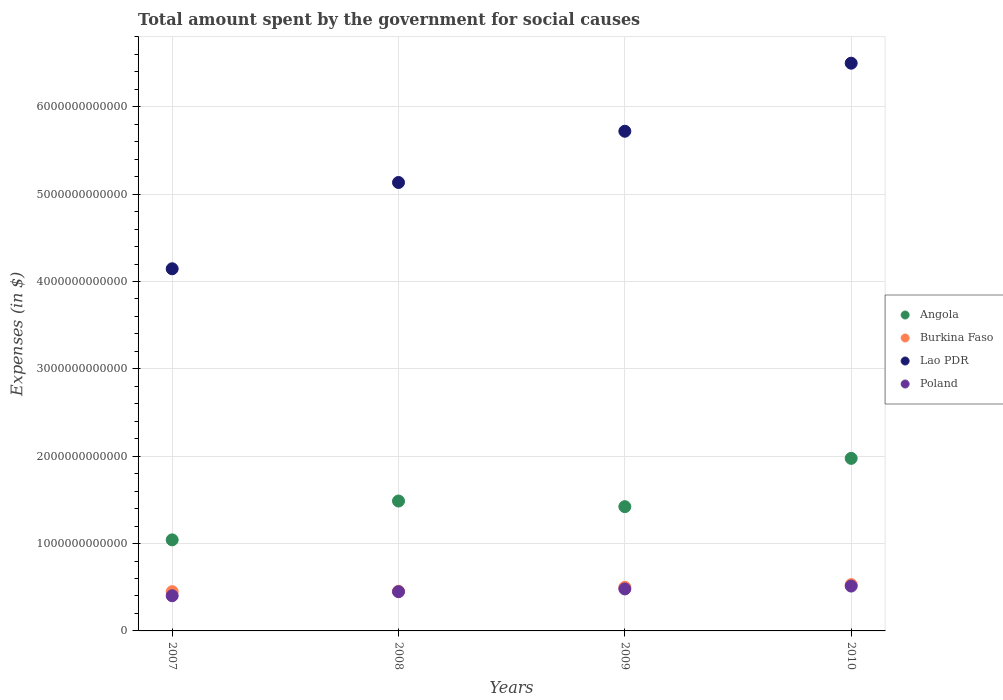How many different coloured dotlines are there?
Your response must be concise. 4. What is the amount spent for social causes by the government in Poland in 2009?
Offer a terse response. 4.81e+11. Across all years, what is the maximum amount spent for social causes by the government in Poland?
Make the answer very short. 5.13e+11. Across all years, what is the minimum amount spent for social causes by the government in Burkina Faso?
Make the answer very short. 4.49e+11. What is the total amount spent for social causes by the government in Poland in the graph?
Your answer should be very brief. 1.85e+12. What is the difference between the amount spent for social causes by the government in Lao PDR in 2009 and that in 2010?
Keep it short and to the point. -7.79e+11. What is the difference between the amount spent for social causes by the government in Poland in 2008 and the amount spent for social causes by the government in Angola in 2009?
Give a very brief answer. -9.73e+11. What is the average amount spent for social causes by the government in Lao PDR per year?
Your answer should be very brief. 5.37e+12. In the year 2009, what is the difference between the amount spent for social causes by the government in Angola and amount spent for social causes by the government in Lao PDR?
Provide a succinct answer. -4.30e+12. In how many years, is the amount spent for social causes by the government in Burkina Faso greater than 4000000000000 $?
Your response must be concise. 0. What is the ratio of the amount spent for social causes by the government in Angola in 2008 to that in 2009?
Give a very brief answer. 1.05. Is the amount spent for social causes by the government in Angola in 2009 less than that in 2010?
Make the answer very short. Yes. Is the difference between the amount spent for social causes by the government in Angola in 2007 and 2010 greater than the difference between the amount spent for social causes by the government in Lao PDR in 2007 and 2010?
Your response must be concise. Yes. What is the difference between the highest and the second highest amount spent for social causes by the government in Lao PDR?
Give a very brief answer. 7.79e+11. What is the difference between the highest and the lowest amount spent for social causes by the government in Angola?
Your answer should be compact. 9.33e+11. Is it the case that in every year, the sum of the amount spent for social causes by the government in Poland and amount spent for social causes by the government in Lao PDR  is greater than the sum of amount spent for social causes by the government in Angola and amount spent for social causes by the government in Burkina Faso?
Your response must be concise. No. Is it the case that in every year, the sum of the amount spent for social causes by the government in Poland and amount spent for social causes by the government in Burkina Faso  is greater than the amount spent for social causes by the government in Lao PDR?
Ensure brevity in your answer.  No. How many dotlines are there?
Offer a terse response. 4. What is the difference between two consecutive major ticks on the Y-axis?
Provide a short and direct response. 1.00e+12. Are the values on the major ticks of Y-axis written in scientific E-notation?
Your answer should be compact. No. Where does the legend appear in the graph?
Give a very brief answer. Center right. How many legend labels are there?
Make the answer very short. 4. What is the title of the graph?
Provide a succinct answer. Total amount spent by the government for social causes. What is the label or title of the X-axis?
Make the answer very short. Years. What is the label or title of the Y-axis?
Offer a very short reply. Expenses (in $). What is the Expenses (in $) in Angola in 2007?
Give a very brief answer. 1.04e+12. What is the Expenses (in $) of Burkina Faso in 2007?
Your response must be concise. 4.49e+11. What is the Expenses (in $) in Lao PDR in 2007?
Make the answer very short. 4.15e+12. What is the Expenses (in $) of Poland in 2007?
Offer a terse response. 4.03e+11. What is the Expenses (in $) in Angola in 2008?
Give a very brief answer. 1.49e+12. What is the Expenses (in $) of Burkina Faso in 2008?
Your response must be concise. 4.54e+11. What is the Expenses (in $) in Lao PDR in 2008?
Keep it short and to the point. 5.13e+12. What is the Expenses (in $) of Poland in 2008?
Offer a terse response. 4.49e+11. What is the Expenses (in $) in Angola in 2009?
Provide a succinct answer. 1.42e+12. What is the Expenses (in $) of Burkina Faso in 2009?
Keep it short and to the point. 4.99e+11. What is the Expenses (in $) of Lao PDR in 2009?
Keep it short and to the point. 5.72e+12. What is the Expenses (in $) in Poland in 2009?
Offer a terse response. 4.81e+11. What is the Expenses (in $) of Angola in 2010?
Ensure brevity in your answer.  1.98e+12. What is the Expenses (in $) of Burkina Faso in 2010?
Keep it short and to the point. 5.30e+11. What is the Expenses (in $) of Lao PDR in 2010?
Offer a terse response. 6.50e+12. What is the Expenses (in $) in Poland in 2010?
Offer a terse response. 5.13e+11. Across all years, what is the maximum Expenses (in $) in Angola?
Your answer should be very brief. 1.98e+12. Across all years, what is the maximum Expenses (in $) of Burkina Faso?
Your response must be concise. 5.30e+11. Across all years, what is the maximum Expenses (in $) of Lao PDR?
Ensure brevity in your answer.  6.50e+12. Across all years, what is the maximum Expenses (in $) in Poland?
Keep it short and to the point. 5.13e+11. Across all years, what is the minimum Expenses (in $) of Angola?
Ensure brevity in your answer.  1.04e+12. Across all years, what is the minimum Expenses (in $) in Burkina Faso?
Offer a very short reply. 4.49e+11. Across all years, what is the minimum Expenses (in $) of Lao PDR?
Your response must be concise. 4.15e+12. Across all years, what is the minimum Expenses (in $) in Poland?
Make the answer very short. 4.03e+11. What is the total Expenses (in $) of Angola in the graph?
Give a very brief answer. 5.93e+12. What is the total Expenses (in $) in Burkina Faso in the graph?
Give a very brief answer. 1.93e+12. What is the total Expenses (in $) of Lao PDR in the graph?
Offer a terse response. 2.15e+13. What is the total Expenses (in $) of Poland in the graph?
Your response must be concise. 1.85e+12. What is the difference between the Expenses (in $) in Angola in 2007 and that in 2008?
Offer a very short reply. -4.45e+11. What is the difference between the Expenses (in $) in Burkina Faso in 2007 and that in 2008?
Provide a short and direct response. -4.22e+09. What is the difference between the Expenses (in $) in Lao PDR in 2007 and that in 2008?
Give a very brief answer. -9.88e+11. What is the difference between the Expenses (in $) of Poland in 2007 and that in 2008?
Your answer should be compact. -4.65e+1. What is the difference between the Expenses (in $) in Angola in 2007 and that in 2009?
Offer a terse response. -3.80e+11. What is the difference between the Expenses (in $) in Burkina Faso in 2007 and that in 2009?
Offer a very short reply. -4.97e+1. What is the difference between the Expenses (in $) in Lao PDR in 2007 and that in 2009?
Your answer should be very brief. -1.57e+12. What is the difference between the Expenses (in $) of Poland in 2007 and that in 2009?
Keep it short and to the point. -7.78e+1. What is the difference between the Expenses (in $) of Angola in 2007 and that in 2010?
Give a very brief answer. -9.33e+11. What is the difference between the Expenses (in $) in Burkina Faso in 2007 and that in 2010?
Make the answer very short. -8.05e+1. What is the difference between the Expenses (in $) in Lao PDR in 2007 and that in 2010?
Your answer should be compact. -2.35e+12. What is the difference between the Expenses (in $) in Poland in 2007 and that in 2010?
Ensure brevity in your answer.  -1.11e+11. What is the difference between the Expenses (in $) of Angola in 2008 and that in 2009?
Give a very brief answer. 6.45e+1. What is the difference between the Expenses (in $) of Burkina Faso in 2008 and that in 2009?
Ensure brevity in your answer.  -4.54e+1. What is the difference between the Expenses (in $) of Lao PDR in 2008 and that in 2009?
Provide a short and direct response. -5.87e+11. What is the difference between the Expenses (in $) in Poland in 2008 and that in 2009?
Keep it short and to the point. -3.14e+1. What is the difference between the Expenses (in $) in Angola in 2008 and that in 2010?
Keep it short and to the point. -4.88e+11. What is the difference between the Expenses (in $) of Burkina Faso in 2008 and that in 2010?
Make the answer very short. -7.63e+1. What is the difference between the Expenses (in $) of Lao PDR in 2008 and that in 2010?
Provide a short and direct response. -1.37e+12. What is the difference between the Expenses (in $) of Poland in 2008 and that in 2010?
Give a very brief answer. -6.41e+1. What is the difference between the Expenses (in $) of Angola in 2009 and that in 2010?
Provide a succinct answer. -5.53e+11. What is the difference between the Expenses (in $) of Burkina Faso in 2009 and that in 2010?
Provide a succinct answer. -3.09e+1. What is the difference between the Expenses (in $) of Lao PDR in 2009 and that in 2010?
Give a very brief answer. -7.79e+11. What is the difference between the Expenses (in $) in Poland in 2009 and that in 2010?
Your answer should be compact. -3.28e+1. What is the difference between the Expenses (in $) in Angola in 2007 and the Expenses (in $) in Burkina Faso in 2008?
Give a very brief answer. 5.89e+11. What is the difference between the Expenses (in $) of Angola in 2007 and the Expenses (in $) of Lao PDR in 2008?
Your answer should be compact. -4.09e+12. What is the difference between the Expenses (in $) of Angola in 2007 and the Expenses (in $) of Poland in 2008?
Offer a very short reply. 5.93e+11. What is the difference between the Expenses (in $) of Burkina Faso in 2007 and the Expenses (in $) of Lao PDR in 2008?
Your answer should be compact. -4.68e+12. What is the difference between the Expenses (in $) of Burkina Faso in 2007 and the Expenses (in $) of Poland in 2008?
Provide a short and direct response. 1.53e+08. What is the difference between the Expenses (in $) in Lao PDR in 2007 and the Expenses (in $) in Poland in 2008?
Give a very brief answer. 3.70e+12. What is the difference between the Expenses (in $) of Angola in 2007 and the Expenses (in $) of Burkina Faso in 2009?
Provide a succinct answer. 5.43e+11. What is the difference between the Expenses (in $) in Angola in 2007 and the Expenses (in $) in Lao PDR in 2009?
Ensure brevity in your answer.  -4.68e+12. What is the difference between the Expenses (in $) of Angola in 2007 and the Expenses (in $) of Poland in 2009?
Offer a terse response. 5.62e+11. What is the difference between the Expenses (in $) of Burkina Faso in 2007 and the Expenses (in $) of Lao PDR in 2009?
Your answer should be very brief. -5.27e+12. What is the difference between the Expenses (in $) in Burkina Faso in 2007 and the Expenses (in $) in Poland in 2009?
Your answer should be very brief. -3.12e+1. What is the difference between the Expenses (in $) of Lao PDR in 2007 and the Expenses (in $) of Poland in 2009?
Make the answer very short. 3.67e+12. What is the difference between the Expenses (in $) of Angola in 2007 and the Expenses (in $) of Burkina Faso in 2010?
Offer a terse response. 5.13e+11. What is the difference between the Expenses (in $) of Angola in 2007 and the Expenses (in $) of Lao PDR in 2010?
Offer a terse response. -5.46e+12. What is the difference between the Expenses (in $) in Angola in 2007 and the Expenses (in $) in Poland in 2010?
Your answer should be compact. 5.29e+11. What is the difference between the Expenses (in $) of Burkina Faso in 2007 and the Expenses (in $) of Lao PDR in 2010?
Keep it short and to the point. -6.05e+12. What is the difference between the Expenses (in $) in Burkina Faso in 2007 and the Expenses (in $) in Poland in 2010?
Your answer should be very brief. -6.40e+1. What is the difference between the Expenses (in $) of Lao PDR in 2007 and the Expenses (in $) of Poland in 2010?
Offer a terse response. 3.63e+12. What is the difference between the Expenses (in $) in Angola in 2008 and the Expenses (in $) in Burkina Faso in 2009?
Offer a terse response. 9.88e+11. What is the difference between the Expenses (in $) in Angola in 2008 and the Expenses (in $) in Lao PDR in 2009?
Offer a terse response. -4.23e+12. What is the difference between the Expenses (in $) of Angola in 2008 and the Expenses (in $) of Poland in 2009?
Your response must be concise. 1.01e+12. What is the difference between the Expenses (in $) of Burkina Faso in 2008 and the Expenses (in $) of Lao PDR in 2009?
Your response must be concise. -5.27e+12. What is the difference between the Expenses (in $) in Burkina Faso in 2008 and the Expenses (in $) in Poland in 2009?
Offer a terse response. -2.70e+1. What is the difference between the Expenses (in $) of Lao PDR in 2008 and the Expenses (in $) of Poland in 2009?
Provide a short and direct response. 4.65e+12. What is the difference between the Expenses (in $) of Angola in 2008 and the Expenses (in $) of Burkina Faso in 2010?
Ensure brevity in your answer.  9.57e+11. What is the difference between the Expenses (in $) of Angola in 2008 and the Expenses (in $) of Lao PDR in 2010?
Give a very brief answer. -5.01e+12. What is the difference between the Expenses (in $) in Angola in 2008 and the Expenses (in $) in Poland in 2010?
Your response must be concise. 9.74e+11. What is the difference between the Expenses (in $) of Burkina Faso in 2008 and the Expenses (in $) of Lao PDR in 2010?
Ensure brevity in your answer.  -6.05e+12. What is the difference between the Expenses (in $) of Burkina Faso in 2008 and the Expenses (in $) of Poland in 2010?
Give a very brief answer. -5.98e+1. What is the difference between the Expenses (in $) of Lao PDR in 2008 and the Expenses (in $) of Poland in 2010?
Provide a short and direct response. 4.62e+12. What is the difference between the Expenses (in $) of Angola in 2009 and the Expenses (in $) of Burkina Faso in 2010?
Your answer should be very brief. 8.93e+11. What is the difference between the Expenses (in $) in Angola in 2009 and the Expenses (in $) in Lao PDR in 2010?
Ensure brevity in your answer.  -5.08e+12. What is the difference between the Expenses (in $) of Angola in 2009 and the Expenses (in $) of Poland in 2010?
Your response must be concise. 9.09e+11. What is the difference between the Expenses (in $) of Burkina Faso in 2009 and the Expenses (in $) of Lao PDR in 2010?
Provide a short and direct response. -6.00e+12. What is the difference between the Expenses (in $) of Burkina Faso in 2009 and the Expenses (in $) of Poland in 2010?
Your answer should be very brief. -1.43e+1. What is the difference between the Expenses (in $) in Lao PDR in 2009 and the Expenses (in $) in Poland in 2010?
Provide a short and direct response. 5.21e+12. What is the average Expenses (in $) of Angola per year?
Make the answer very short. 1.48e+12. What is the average Expenses (in $) in Burkina Faso per year?
Provide a succinct answer. 4.83e+11. What is the average Expenses (in $) of Lao PDR per year?
Offer a very short reply. 5.37e+12. What is the average Expenses (in $) in Poland per year?
Give a very brief answer. 4.62e+11. In the year 2007, what is the difference between the Expenses (in $) of Angola and Expenses (in $) of Burkina Faso?
Provide a succinct answer. 5.93e+11. In the year 2007, what is the difference between the Expenses (in $) in Angola and Expenses (in $) in Lao PDR?
Keep it short and to the point. -3.10e+12. In the year 2007, what is the difference between the Expenses (in $) of Angola and Expenses (in $) of Poland?
Offer a terse response. 6.40e+11. In the year 2007, what is the difference between the Expenses (in $) in Burkina Faso and Expenses (in $) in Lao PDR?
Give a very brief answer. -3.70e+12. In the year 2007, what is the difference between the Expenses (in $) of Burkina Faso and Expenses (in $) of Poland?
Ensure brevity in your answer.  4.66e+1. In the year 2007, what is the difference between the Expenses (in $) in Lao PDR and Expenses (in $) in Poland?
Offer a very short reply. 3.74e+12. In the year 2008, what is the difference between the Expenses (in $) of Angola and Expenses (in $) of Burkina Faso?
Keep it short and to the point. 1.03e+12. In the year 2008, what is the difference between the Expenses (in $) of Angola and Expenses (in $) of Lao PDR?
Provide a succinct answer. -3.65e+12. In the year 2008, what is the difference between the Expenses (in $) in Angola and Expenses (in $) in Poland?
Provide a succinct answer. 1.04e+12. In the year 2008, what is the difference between the Expenses (in $) in Burkina Faso and Expenses (in $) in Lao PDR?
Provide a short and direct response. -4.68e+12. In the year 2008, what is the difference between the Expenses (in $) of Burkina Faso and Expenses (in $) of Poland?
Your answer should be very brief. 4.37e+09. In the year 2008, what is the difference between the Expenses (in $) in Lao PDR and Expenses (in $) in Poland?
Offer a terse response. 4.68e+12. In the year 2009, what is the difference between the Expenses (in $) in Angola and Expenses (in $) in Burkina Faso?
Provide a short and direct response. 9.24e+11. In the year 2009, what is the difference between the Expenses (in $) of Angola and Expenses (in $) of Lao PDR?
Keep it short and to the point. -4.30e+12. In the year 2009, what is the difference between the Expenses (in $) in Angola and Expenses (in $) in Poland?
Ensure brevity in your answer.  9.42e+11. In the year 2009, what is the difference between the Expenses (in $) in Burkina Faso and Expenses (in $) in Lao PDR?
Provide a short and direct response. -5.22e+12. In the year 2009, what is the difference between the Expenses (in $) of Burkina Faso and Expenses (in $) of Poland?
Offer a very short reply. 1.84e+1. In the year 2009, what is the difference between the Expenses (in $) in Lao PDR and Expenses (in $) in Poland?
Your response must be concise. 5.24e+12. In the year 2010, what is the difference between the Expenses (in $) of Angola and Expenses (in $) of Burkina Faso?
Offer a terse response. 1.45e+12. In the year 2010, what is the difference between the Expenses (in $) in Angola and Expenses (in $) in Lao PDR?
Give a very brief answer. -4.52e+12. In the year 2010, what is the difference between the Expenses (in $) in Angola and Expenses (in $) in Poland?
Your answer should be very brief. 1.46e+12. In the year 2010, what is the difference between the Expenses (in $) of Burkina Faso and Expenses (in $) of Lao PDR?
Make the answer very short. -5.97e+12. In the year 2010, what is the difference between the Expenses (in $) in Burkina Faso and Expenses (in $) in Poland?
Make the answer very short. 1.66e+1. In the year 2010, what is the difference between the Expenses (in $) in Lao PDR and Expenses (in $) in Poland?
Offer a terse response. 5.99e+12. What is the ratio of the Expenses (in $) in Angola in 2007 to that in 2008?
Your response must be concise. 0.7. What is the ratio of the Expenses (in $) of Burkina Faso in 2007 to that in 2008?
Your answer should be compact. 0.99. What is the ratio of the Expenses (in $) in Lao PDR in 2007 to that in 2008?
Your response must be concise. 0.81. What is the ratio of the Expenses (in $) of Poland in 2007 to that in 2008?
Offer a very short reply. 0.9. What is the ratio of the Expenses (in $) of Angola in 2007 to that in 2009?
Keep it short and to the point. 0.73. What is the ratio of the Expenses (in $) of Burkina Faso in 2007 to that in 2009?
Provide a short and direct response. 0.9. What is the ratio of the Expenses (in $) of Lao PDR in 2007 to that in 2009?
Keep it short and to the point. 0.72. What is the ratio of the Expenses (in $) in Poland in 2007 to that in 2009?
Your answer should be very brief. 0.84. What is the ratio of the Expenses (in $) in Angola in 2007 to that in 2010?
Make the answer very short. 0.53. What is the ratio of the Expenses (in $) in Burkina Faso in 2007 to that in 2010?
Make the answer very short. 0.85. What is the ratio of the Expenses (in $) in Lao PDR in 2007 to that in 2010?
Provide a short and direct response. 0.64. What is the ratio of the Expenses (in $) in Poland in 2007 to that in 2010?
Give a very brief answer. 0.78. What is the ratio of the Expenses (in $) of Angola in 2008 to that in 2009?
Keep it short and to the point. 1.05. What is the ratio of the Expenses (in $) of Burkina Faso in 2008 to that in 2009?
Your response must be concise. 0.91. What is the ratio of the Expenses (in $) of Lao PDR in 2008 to that in 2009?
Offer a terse response. 0.9. What is the ratio of the Expenses (in $) in Poland in 2008 to that in 2009?
Your response must be concise. 0.93. What is the ratio of the Expenses (in $) in Angola in 2008 to that in 2010?
Ensure brevity in your answer.  0.75. What is the ratio of the Expenses (in $) in Burkina Faso in 2008 to that in 2010?
Your answer should be very brief. 0.86. What is the ratio of the Expenses (in $) of Lao PDR in 2008 to that in 2010?
Your answer should be very brief. 0.79. What is the ratio of the Expenses (in $) of Poland in 2008 to that in 2010?
Provide a succinct answer. 0.88. What is the ratio of the Expenses (in $) in Angola in 2009 to that in 2010?
Offer a very short reply. 0.72. What is the ratio of the Expenses (in $) of Burkina Faso in 2009 to that in 2010?
Provide a short and direct response. 0.94. What is the ratio of the Expenses (in $) of Lao PDR in 2009 to that in 2010?
Provide a succinct answer. 0.88. What is the ratio of the Expenses (in $) of Poland in 2009 to that in 2010?
Provide a short and direct response. 0.94. What is the difference between the highest and the second highest Expenses (in $) in Angola?
Ensure brevity in your answer.  4.88e+11. What is the difference between the highest and the second highest Expenses (in $) of Burkina Faso?
Provide a succinct answer. 3.09e+1. What is the difference between the highest and the second highest Expenses (in $) of Lao PDR?
Your answer should be compact. 7.79e+11. What is the difference between the highest and the second highest Expenses (in $) in Poland?
Ensure brevity in your answer.  3.28e+1. What is the difference between the highest and the lowest Expenses (in $) in Angola?
Keep it short and to the point. 9.33e+11. What is the difference between the highest and the lowest Expenses (in $) in Burkina Faso?
Your answer should be very brief. 8.05e+1. What is the difference between the highest and the lowest Expenses (in $) of Lao PDR?
Your response must be concise. 2.35e+12. What is the difference between the highest and the lowest Expenses (in $) of Poland?
Give a very brief answer. 1.11e+11. 